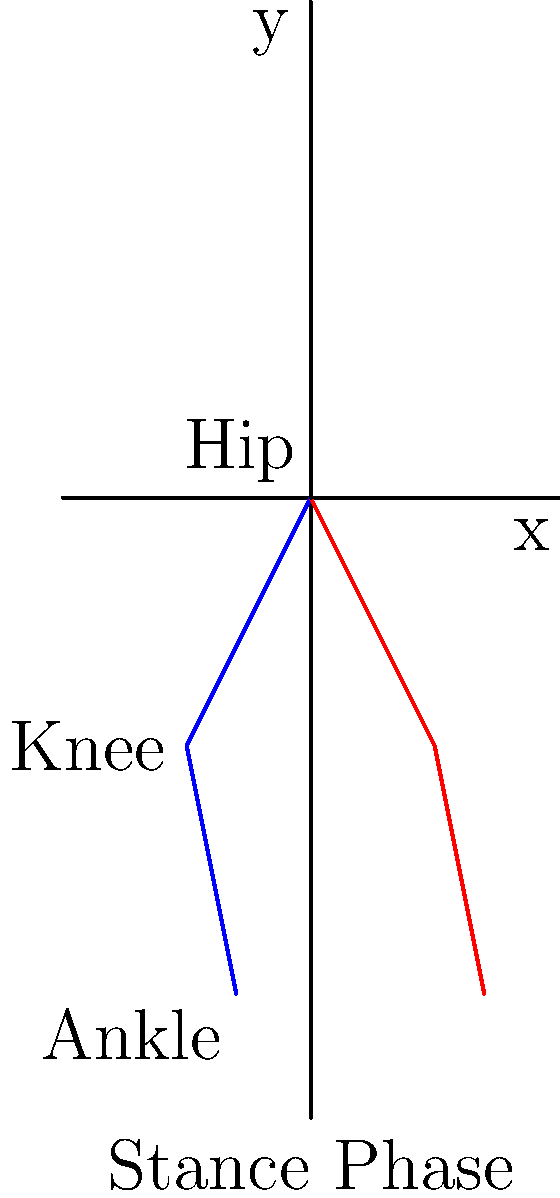In the context of joint kinematics during gait analysis, consider the stick figure diagram representing the stance phase of human walking. Which joint typically exhibits the greatest range of motion in the sagittal plane during this phase, and how might quantum effects potentially influence the precision of its measurement? To answer this question, let's break it down step-by-step:

1. Joint kinematics in gait analysis:
   - The main joints involved in the lower limb during gait are the hip, knee, and ankle.
   - The sagittal plane is the plane that divides the body into left and right halves.

2. Range of motion during stance phase:
   - Hip: Typically moves from slight flexion to extension (relatively small range).
   - Knee: Starts slightly flexed, then extends and slightly flexes again (moderate range).
   - Ankle: Moves from dorsiflexion at heel strike to plantarflexion at toe-off (largest range).

3. Greatest range of motion:
   - The ankle joint exhibits the greatest range of motion in the sagittal plane during the stance phase.
   - This is due to the significant plantarflexion required for push-off at the end of the stance phase.

4. Quantum effects on measurement precision:
   - Quantum phenomena could potentially influence measurement precision through:
     a. Heisenberg's uncertainty principle: There's a fundamental limit to the precision with which certain pairs of physical properties can be determined.
     b. Quantum coherence: Biological systems might exhibit quantum coherence, which could affect the behavior of molecules involved in joint movement.
     c. Quantum tunneling: This could influence the behavior of ions in nerve signaling, potentially affecting the precision of muscle activation and joint movement.

5. Implications for joint kinematics measurement:
   - These quantum effects could introduce minute variations in joint angles or velocities.
   - While typically negligible at the macroscopic level of joint movement, these effects might become relevant when attempting to achieve extremely high precision measurements.
   - Understanding these quantum influences could be crucial for developing ultra-precise motion capture technologies or for studying the fundamental limits of biological motion.
Answer: Ankle joint; quantum effects may introduce minute uncertainties in measurement precision. 